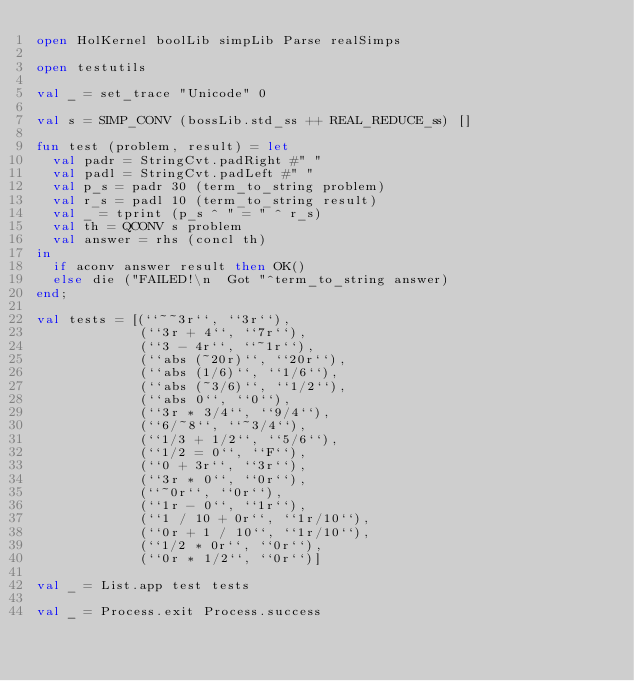<code> <loc_0><loc_0><loc_500><loc_500><_SML_>open HolKernel boolLib simpLib Parse realSimps

open testutils

val _ = set_trace "Unicode" 0

val s = SIMP_CONV (bossLib.std_ss ++ REAL_REDUCE_ss) []

fun test (problem, result) = let
  val padr = StringCvt.padRight #" "
  val padl = StringCvt.padLeft #" "
  val p_s = padr 30 (term_to_string problem)
  val r_s = padl 10 (term_to_string result)
  val _ = tprint (p_s ^ " = " ^ r_s)
  val th = QCONV s problem
  val answer = rhs (concl th)
in
  if aconv answer result then OK()
  else die ("FAILED!\n  Got "^term_to_string answer)
end;

val tests = [(``~~3r``, ``3r``),
             (``3r + 4``, ``7r``),
             (``3 - 4r``, ``~1r``),
             (``abs (~20r)``, ``20r``),
             (``abs (1/6)``, ``1/6``),
             (``abs (~3/6)``, ``1/2``),
             (``abs 0``, ``0``),
             (``3r * 3/4``, ``9/4``),
             (``6/~8``, ``~3/4``),
             (``1/3 + 1/2``, ``5/6``),
             (``1/2 = 0``, ``F``),
             (``0 + 3r``, ``3r``),
             (``3r * 0``, ``0r``),
             (``~0r``, ``0r``),
             (``1r - 0``, ``1r``),
             (``1 / 10 + 0r``, ``1r/10``),
             (``0r + 1 / 10``, ``1r/10``),
             (``1/2 * 0r``, ``0r``),
             (``0r * 1/2``, ``0r``)]

val _ = List.app test tests

val _ = Process.exit Process.success
</code> 